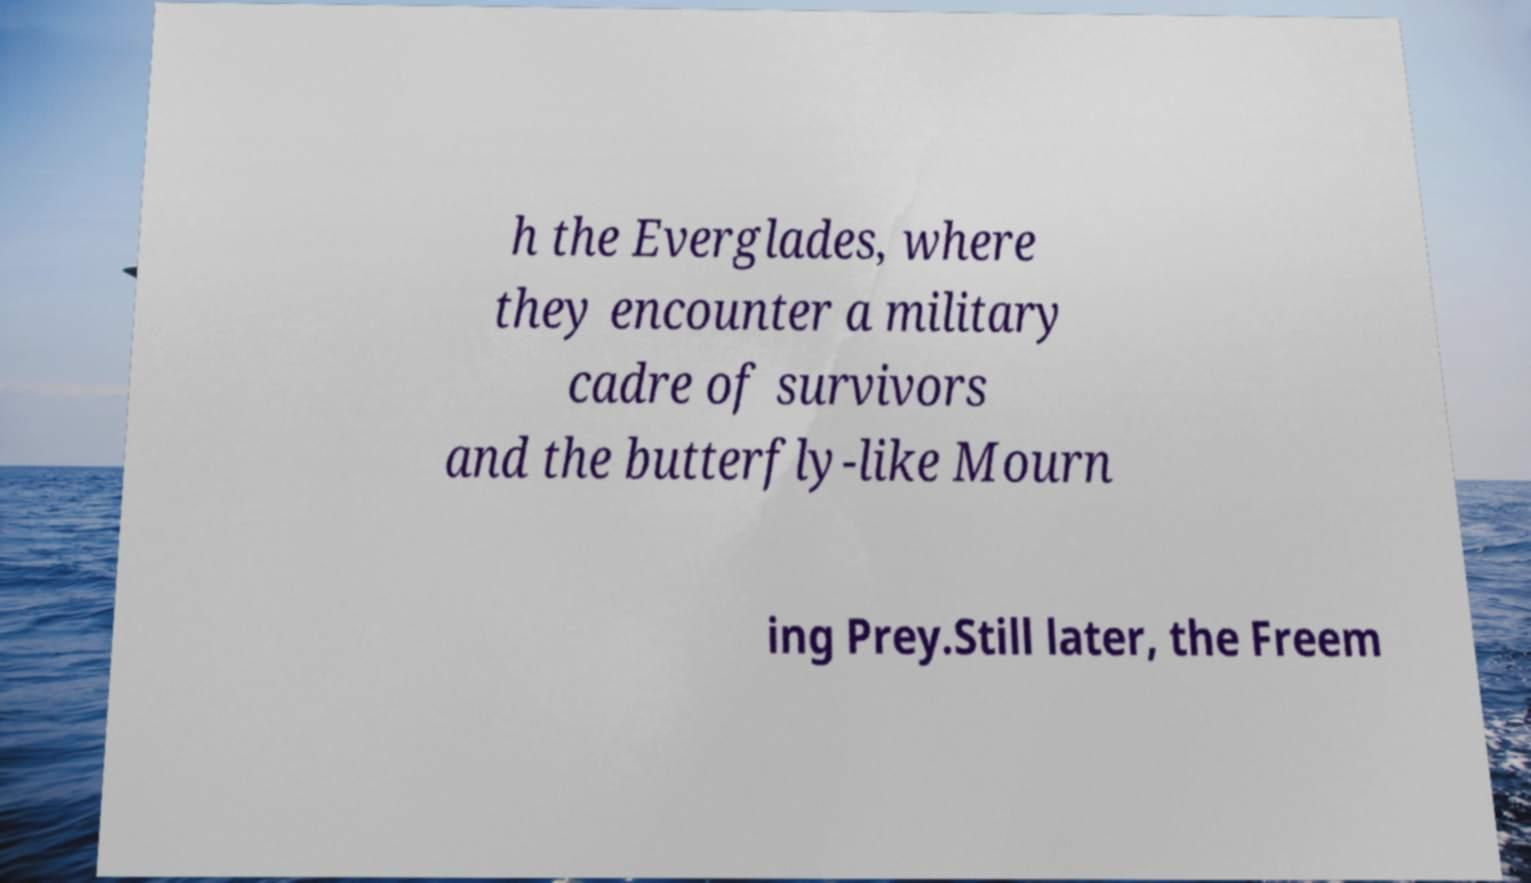Can you read and provide the text displayed in the image?This photo seems to have some interesting text. Can you extract and type it out for me? h the Everglades, where they encounter a military cadre of survivors and the butterfly-like Mourn ing Prey.Still later, the Freem 